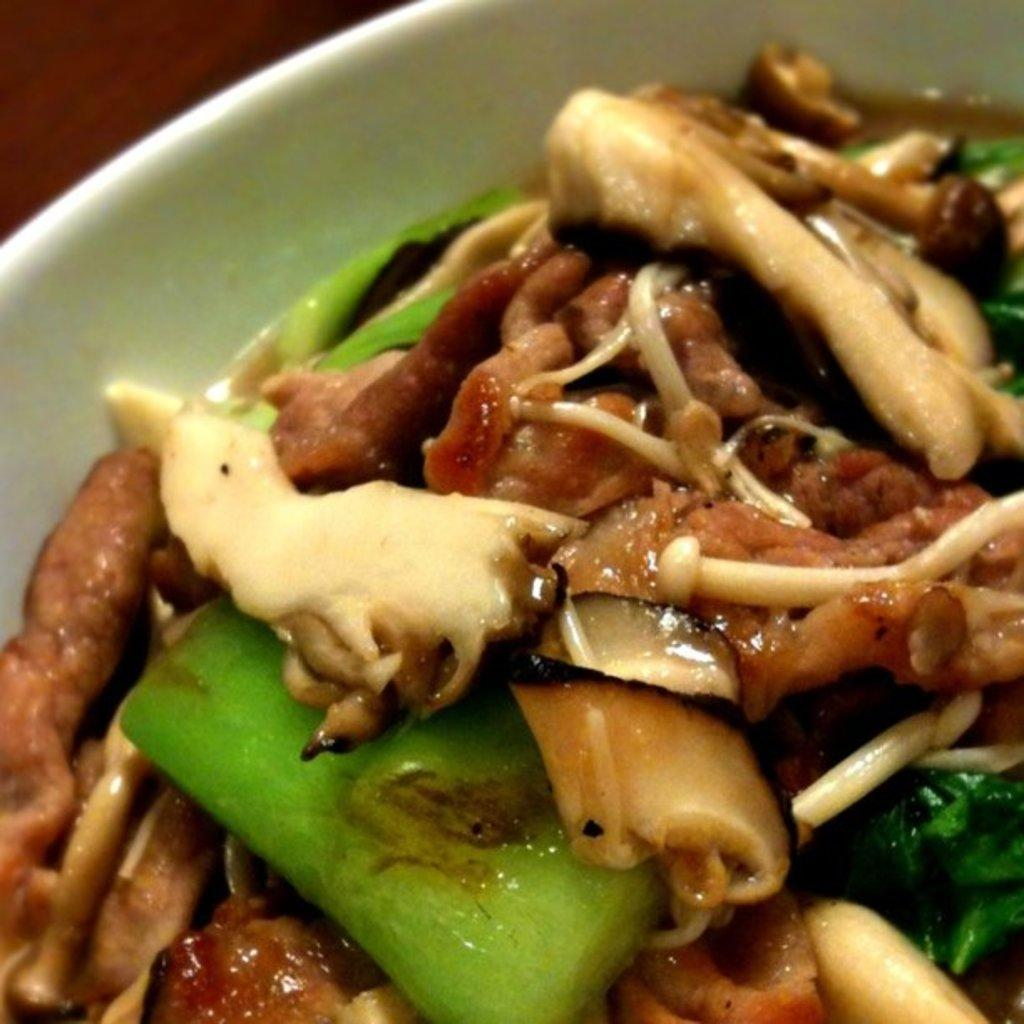What is the focus of the image? The image is zoomed in on a white color palette. What can be found on the palette? The palette contains some food items. What color is the palette? The palette is white. Is there anything else visible in the background of the image? Yes, there is a brown color object in the background of the image. How many people are exchanging items in the crowd in the image? There is no crowd or exchange of items present in the image; it only features a white color palette with food items and a brown object in the background. 